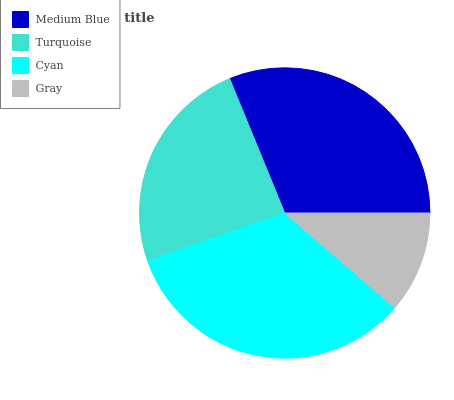Is Gray the minimum?
Answer yes or no. Yes. Is Cyan the maximum?
Answer yes or no. Yes. Is Turquoise the minimum?
Answer yes or no. No. Is Turquoise the maximum?
Answer yes or no. No. Is Medium Blue greater than Turquoise?
Answer yes or no. Yes. Is Turquoise less than Medium Blue?
Answer yes or no. Yes. Is Turquoise greater than Medium Blue?
Answer yes or no. No. Is Medium Blue less than Turquoise?
Answer yes or no. No. Is Medium Blue the high median?
Answer yes or no. Yes. Is Turquoise the low median?
Answer yes or no. Yes. Is Gray the high median?
Answer yes or no. No. Is Medium Blue the low median?
Answer yes or no. No. 